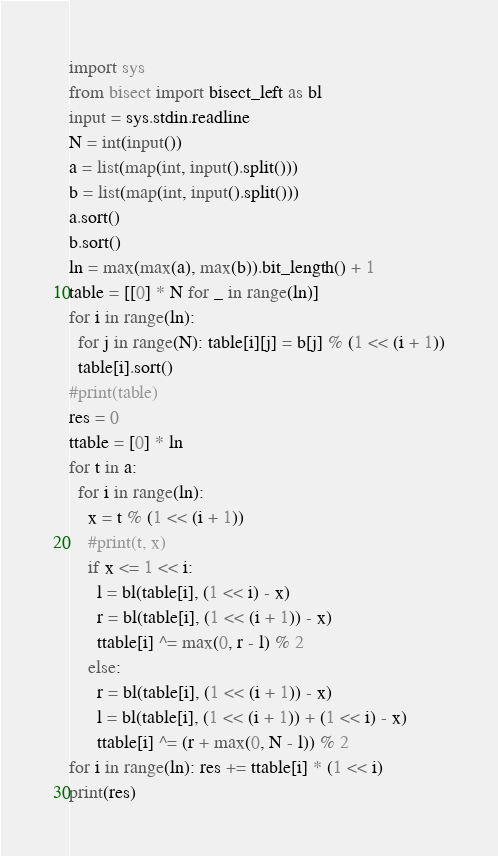<code> <loc_0><loc_0><loc_500><loc_500><_Python_>import sys
from bisect import bisect_left as bl
input = sys.stdin.readline
N = int(input())
a = list(map(int, input().split()))
b = list(map(int, input().split()))
a.sort()
b.sort()
ln = max(max(a), max(b)).bit_length() + 1
table = [[0] * N for _ in range(ln)]
for i in range(ln):
  for j in range(N): table[i][j] = b[j] % (1 << (i + 1))
  table[i].sort()
#print(table)
res = 0
ttable = [0] * ln
for t in a:
  for i in range(ln):
    x = t % (1 << (i + 1))
    #print(t, x)
    if x <= 1 << i:
      l = bl(table[i], (1 << i) - x)
      r = bl(table[i], (1 << (i + 1)) - x)
      ttable[i] ^= max(0, r - l) % 2
    else:
      r = bl(table[i], (1 << (i + 1)) - x)
      l = bl(table[i], (1 << (i + 1)) + (1 << i) - x)
      ttable[i] ^= (r + max(0, N - l)) % 2
for i in range(ln): res += ttable[i] * (1 << i)
print(res)</code> 